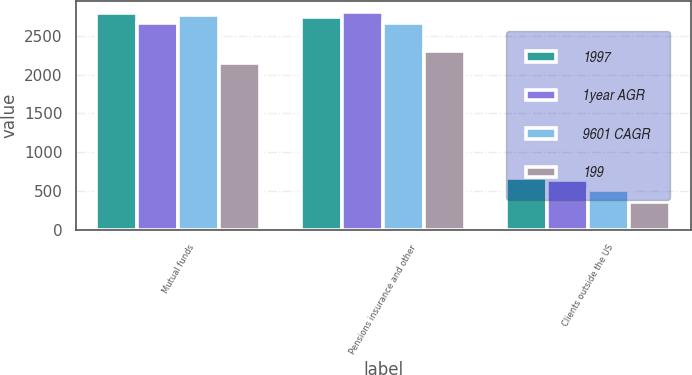Convert chart to OTSL. <chart><loc_0><loc_0><loc_500><loc_500><stacked_bar_chart><ecel><fcel>Mutual funds<fcel>Pensions insurance and other<fcel>Clients outside the US<nl><fcel>1997<fcel>2794<fcel>2737<fcel>672<nl><fcel>1year AGR<fcel>2664<fcel>2803<fcel>651<nl><fcel>9601 CAGR<fcel>2769<fcel>2669<fcel>514<nl><fcel>199<fcel>2144<fcel>2306<fcel>362<nl></chart> 